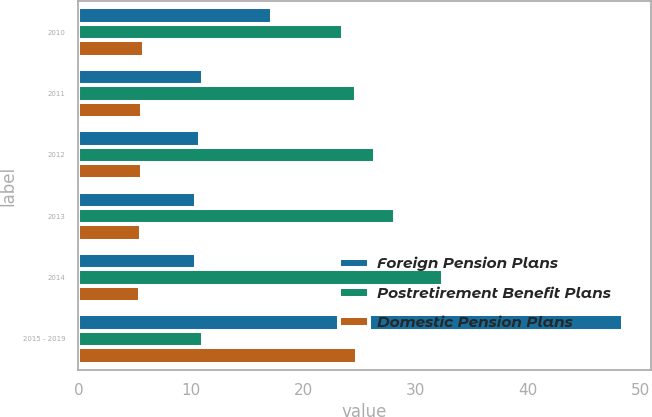Convert chart to OTSL. <chart><loc_0><loc_0><loc_500><loc_500><stacked_bar_chart><ecel><fcel>2010<fcel>2011<fcel>2012<fcel>2013<fcel>2014<fcel>2015 - 2019<nl><fcel>Foreign Pension Plans<fcel>17.2<fcel>11.1<fcel>10.8<fcel>10.5<fcel>10.5<fcel>48.5<nl><fcel>Postretirement Benefit Plans<fcel>23.5<fcel>24.7<fcel>26.4<fcel>28.2<fcel>32.4<fcel>11.1<nl><fcel>Domestic Pension Plans<fcel>5.8<fcel>5.7<fcel>5.7<fcel>5.6<fcel>5.5<fcel>24.8<nl></chart> 